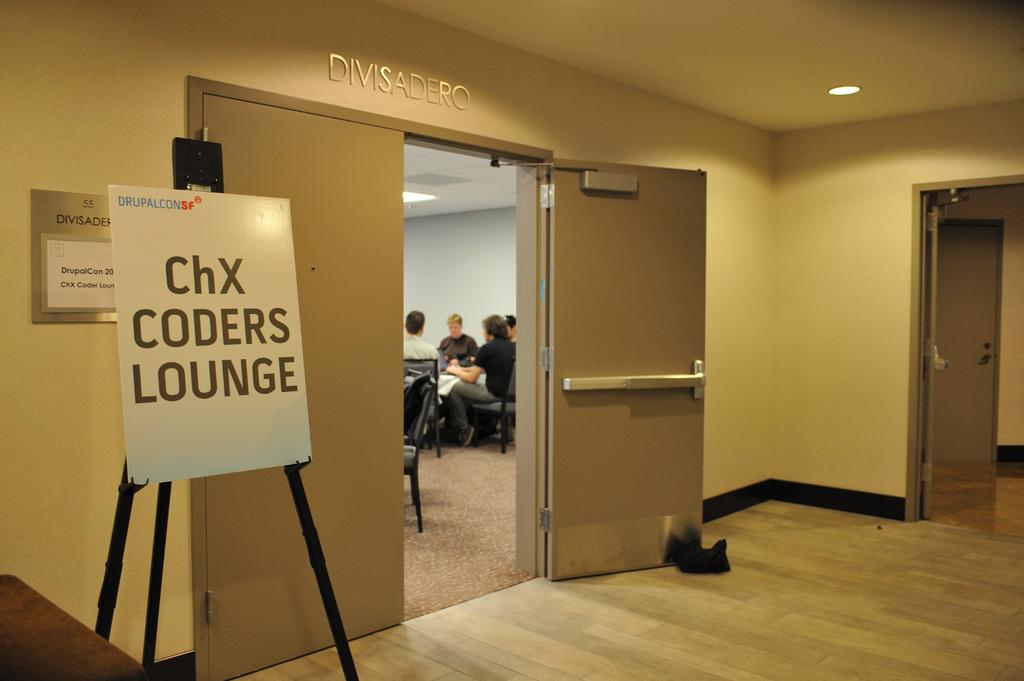What is the main object in the image? There is a whiteboard in the image. What is on the whiteboard? Something is written on the whiteboard. What can be seen in the background of the image? There are people sitting on chairs and doors visible in the background. How many snakes are crawling on the whiteboard in the image? There are no snakes present on the whiteboard or in the image. What are the boys doing in the image? There is no mention of boys in the image, so we cannot determine what they might be doing. 